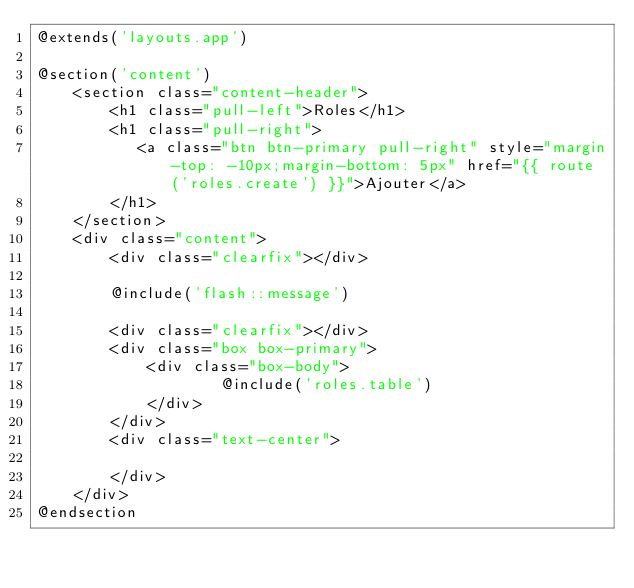Convert code to text. <code><loc_0><loc_0><loc_500><loc_500><_PHP_>@extends('layouts.app')

@section('content')
    <section class="content-header">
        <h1 class="pull-left">Roles</h1>
        <h1 class="pull-right">
           <a class="btn btn-primary pull-right" style="margin-top: -10px;margin-bottom: 5px" href="{{ route('roles.create') }}">Ajouter</a>
        </h1>
    </section>
    <div class="content">
        <div class="clearfix"></div>

        @include('flash::message')

        <div class="clearfix"></div>
        <div class="box box-primary">
            <div class="box-body">
                    @include('roles.table')
            </div>
        </div>
        <div class="text-center">
        
        </div>
    </div>
@endsection

</code> 